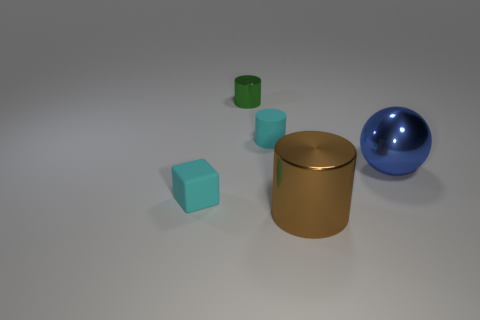Do the small matte block and the matte cylinder have the same color?
Make the answer very short. Yes. There is a matte object right of the metallic object that is to the left of the large thing on the left side of the blue object; what size is it?
Your response must be concise. Small. There is a tiny object that is behind the cyan thing on the right side of the metallic cylinder behind the cyan block; what shape is it?
Give a very brief answer. Cylinder. There is a big thing that is in front of the large metallic ball; what is its shape?
Ensure brevity in your answer.  Cylinder. Is the material of the big blue sphere the same as the small cyan thing that is to the right of the tiny green cylinder?
Make the answer very short. No. How many other things are the same shape as the blue metal object?
Offer a terse response. 0. There is a tiny rubber cylinder; is its color the same as the rubber object in front of the big sphere?
Make the answer very short. Yes. What shape is the rubber thing to the left of the small cyan thing behind the tiny cyan cube?
Make the answer very short. Cube. Do the cyan matte thing left of the green metal thing and the big blue thing have the same shape?
Offer a terse response. No. Is the number of green metallic objects behind the large blue thing greater than the number of blue objects behind the tiny green metallic thing?
Make the answer very short. Yes. 